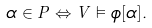Convert formula to latex. <formula><loc_0><loc_0><loc_500><loc_500>\alpha \in P \Leftrightarrow V \vDash \phi [ \alpha ] .</formula> 